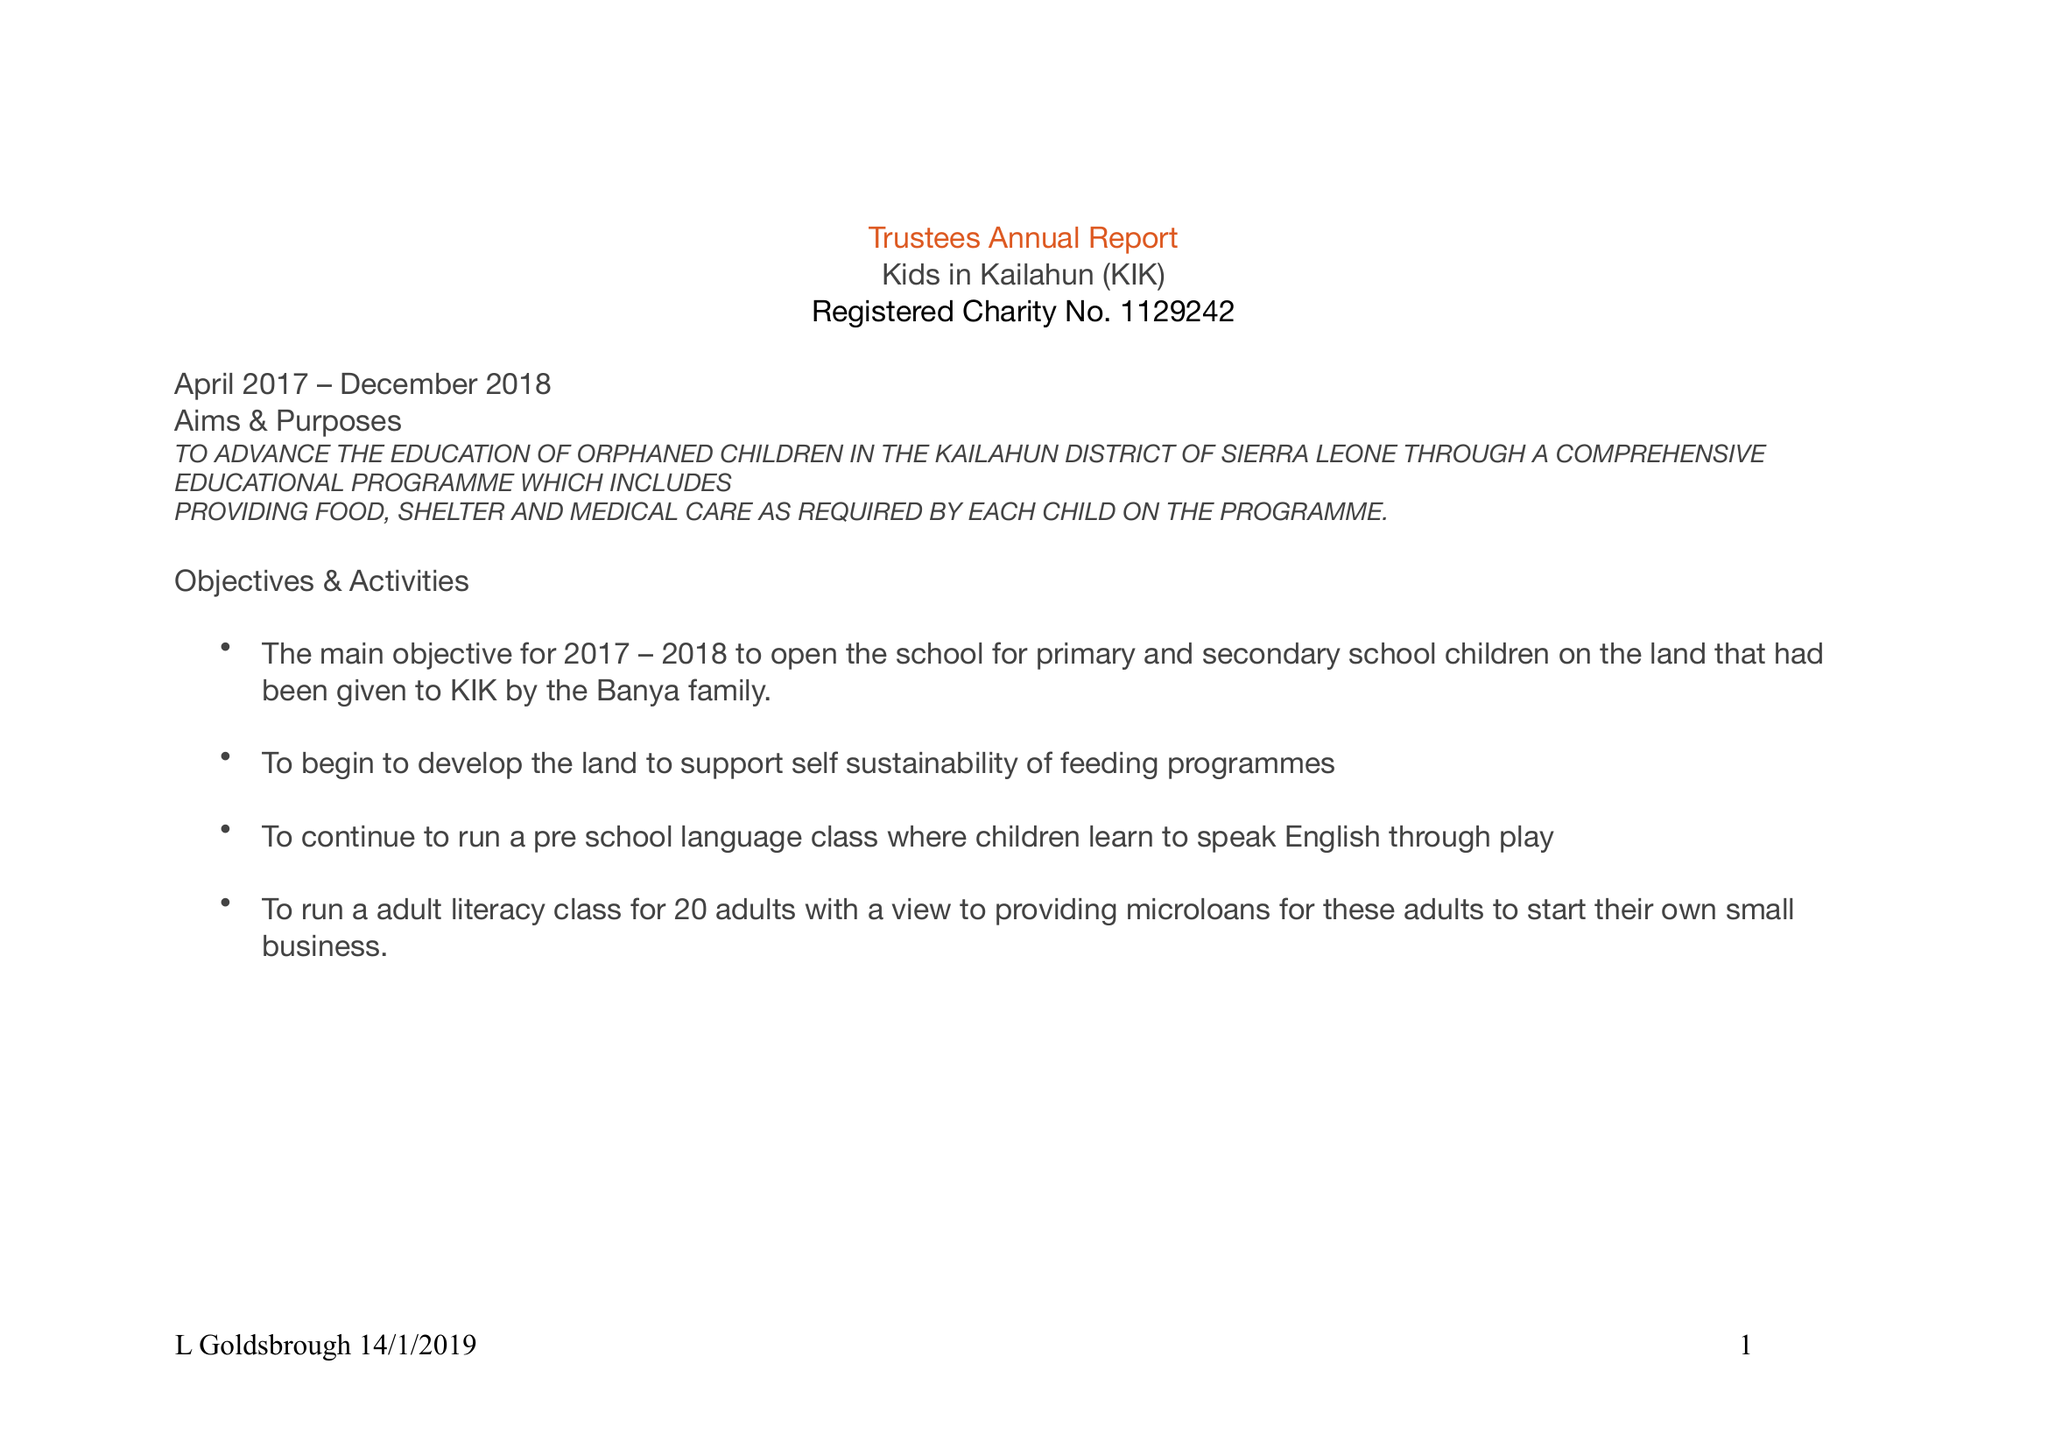What is the value for the address__street_line?
Answer the question using a single word or phrase. 2 PENDLE VIEW 